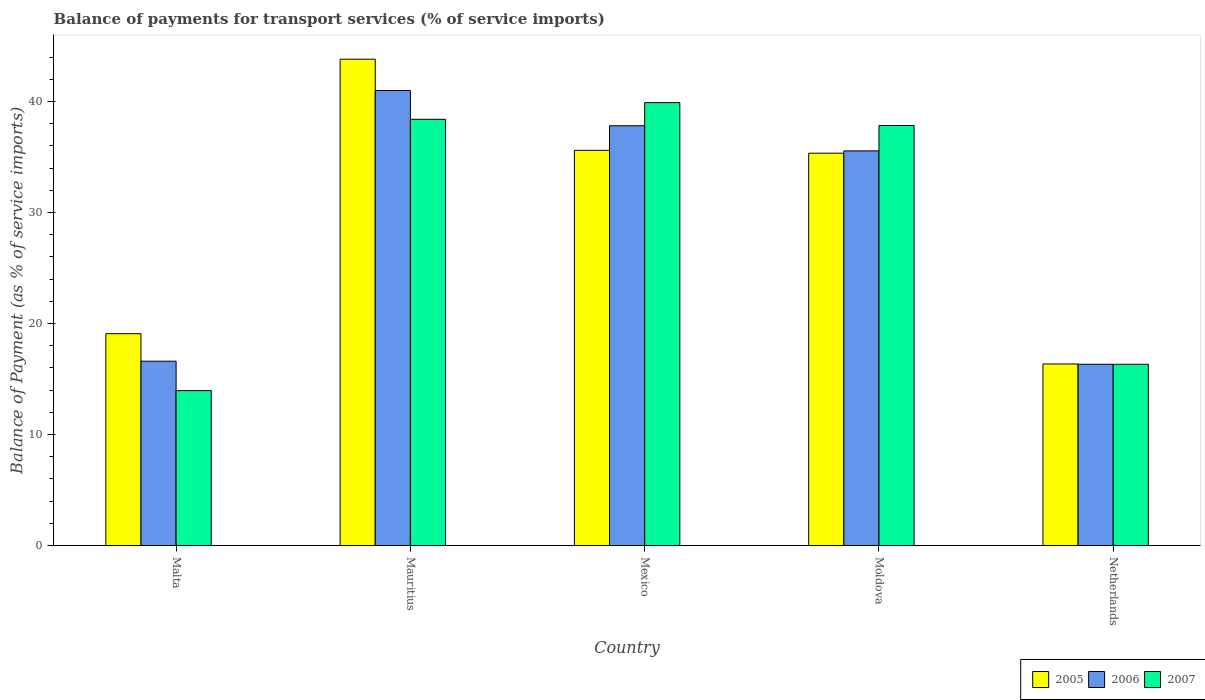How many different coloured bars are there?
Make the answer very short. 3. How many groups of bars are there?
Offer a terse response. 5. Are the number of bars per tick equal to the number of legend labels?
Ensure brevity in your answer.  Yes. What is the label of the 4th group of bars from the left?
Offer a terse response. Moldova. In how many cases, is the number of bars for a given country not equal to the number of legend labels?
Ensure brevity in your answer.  0. What is the balance of payments for transport services in 2007 in Moldova?
Offer a terse response. 37.83. Across all countries, what is the maximum balance of payments for transport services in 2007?
Give a very brief answer. 39.9. Across all countries, what is the minimum balance of payments for transport services in 2005?
Provide a succinct answer. 16.35. In which country was the balance of payments for transport services in 2007 maximum?
Your response must be concise. Mexico. In which country was the balance of payments for transport services in 2005 minimum?
Ensure brevity in your answer.  Netherlands. What is the total balance of payments for transport services in 2005 in the graph?
Offer a very short reply. 150.18. What is the difference between the balance of payments for transport services in 2005 in Malta and that in Mauritius?
Make the answer very short. -24.72. What is the difference between the balance of payments for transport services in 2007 in Moldova and the balance of payments for transport services in 2006 in Mauritius?
Offer a very short reply. -3.15. What is the average balance of payments for transport services in 2005 per country?
Your answer should be very brief. 30.04. What is the difference between the balance of payments for transport services of/in 2007 and balance of payments for transport services of/in 2005 in Mexico?
Your answer should be compact. 4.3. In how many countries, is the balance of payments for transport services in 2005 greater than 22 %?
Offer a very short reply. 3. What is the ratio of the balance of payments for transport services in 2005 in Mauritius to that in Mexico?
Your answer should be compact. 1.23. Is the difference between the balance of payments for transport services in 2007 in Malta and Mauritius greater than the difference between the balance of payments for transport services in 2005 in Malta and Mauritius?
Provide a succinct answer. Yes. What is the difference between the highest and the second highest balance of payments for transport services in 2007?
Give a very brief answer. -0.56. What is the difference between the highest and the lowest balance of payments for transport services in 2006?
Provide a succinct answer. 24.65. How many countries are there in the graph?
Offer a very short reply. 5. Are the values on the major ticks of Y-axis written in scientific E-notation?
Provide a short and direct response. No. Does the graph contain grids?
Provide a succinct answer. No. What is the title of the graph?
Ensure brevity in your answer.  Balance of payments for transport services (% of service imports). Does "2014" appear as one of the legend labels in the graph?
Offer a terse response. No. What is the label or title of the X-axis?
Provide a succinct answer. Country. What is the label or title of the Y-axis?
Your answer should be compact. Balance of Payment (as % of service imports). What is the Balance of Payment (as % of service imports) in 2005 in Malta?
Your answer should be compact. 19.08. What is the Balance of Payment (as % of service imports) of 2006 in Malta?
Keep it short and to the point. 16.61. What is the Balance of Payment (as % of service imports) in 2007 in Malta?
Ensure brevity in your answer.  13.96. What is the Balance of Payment (as % of service imports) in 2005 in Mauritius?
Your answer should be compact. 43.81. What is the Balance of Payment (as % of service imports) of 2006 in Mauritius?
Your answer should be very brief. 40.98. What is the Balance of Payment (as % of service imports) of 2007 in Mauritius?
Offer a terse response. 38.39. What is the Balance of Payment (as % of service imports) of 2005 in Mexico?
Offer a terse response. 35.6. What is the Balance of Payment (as % of service imports) of 2006 in Mexico?
Your answer should be compact. 37.81. What is the Balance of Payment (as % of service imports) of 2007 in Mexico?
Give a very brief answer. 39.9. What is the Balance of Payment (as % of service imports) of 2005 in Moldova?
Your answer should be compact. 35.34. What is the Balance of Payment (as % of service imports) of 2006 in Moldova?
Keep it short and to the point. 35.55. What is the Balance of Payment (as % of service imports) in 2007 in Moldova?
Ensure brevity in your answer.  37.83. What is the Balance of Payment (as % of service imports) of 2005 in Netherlands?
Keep it short and to the point. 16.35. What is the Balance of Payment (as % of service imports) in 2006 in Netherlands?
Give a very brief answer. 16.33. What is the Balance of Payment (as % of service imports) of 2007 in Netherlands?
Your response must be concise. 16.33. Across all countries, what is the maximum Balance of Payment (as % of service imports) of 2005?
Ensure brevity in your answer.  43.81. Across all countries, what is the maximum Balance of Payment (as % of service imports) of 2006?
Ensure brevity in your answer.  40.98. Across all countries, what is the maximum Balance of Payment (as % of service imports) in 2007?
Give a very brief answer. 39.9. Across all countries, what is the minimum Balance of Payment (as % of service imports) in 2005?
Give a very brief answer. 16.35. Across all countries, what is the minimum Balance of Payment (as % of service imports) in 2006?
Provide a succinct answer. 16.33. Across all countries, what is the minimum Balance of Payment (as % of service imports) in 2007?
Provide a succinct answer. 13.96. What is the total Balance of Payment (as % of service imports) of 2005 in the graph?
Keep it short and to the point. 150.18. What is the total Balance of Payment (as % of service imports) of 2006 in the graph?
Offer a terse response. 147.28. What is the total Balance of Payment (as % of service imports) of 2007 in the graph?
Offer a very short reply. 146.41. What is the difference between the Balance of Payment (as % of service imports) of 2005 in Malta and that in Mauritius?
Offer a terse response. -24.72. What is the difference between the Balance of Payment (as % of service imports) in 2006 in Malta and that in Mauritius?
Your response must be concise. -24.38. What is the difference between the Balance of Payment (as % of service imports) in 2007 in Malta and that in Mauritius?
Give a very brief answer. -24.44. What is the difference between the Balance of Payment (as % of service imports) of 2005 in Malta and that in Mexico?
Offer a very short reply. -16.51. What is the difference between the Balance of Payment (as % of service imports) of 2006 in Malta and that in Mexico?
Give a very brief answer. -21.21. What is the difference between the Balance of Payment (as % of service imports) in 2007 in Malta and that in Mexico?
Your answer should be compact. -25.94. What is the difference between the Balance of Payment (as % of service imports) of 2005 in Malta and that in Moldova?
Offer a terse response. -16.25. What is the difference between the Balance of Payment (as % of service imports) in 2006 in Malta and that in Moldova?
Keep it short and to the point. -18.94. What is the difference between the Balance of Payment (as % of service imports) in 2007 in Malta and that in Moldova?
Offer a very short reply. -23.88. What is the difference between the Balance of Payment (as % of service imports) in 2005 in Malta and that in Netherlands?
Your response must be concise. 2.73. What is the difference between the Balance of Payment (as % of service imports) in 2006 in Malta and that in Netherlands?
Offer a very short reply. 0.28. What is the difference between the Balance of Payment (as % of service imports) of 2007 in Malta and that in Netherlands?
Give a very brief answer. -2.37. What is the difference between the Balance of Payment (as % of service imports) in 2005 in Mauritius and that in Mexico?
Your response must be concise. 8.21. What is the difference between the Balance of Payment (as % of service imports) in 2006 in Mauritius and that in Mexico?
Your response must be concise. 3.17. What is the difference between the Balance of Payment (as % of service imports) in 2007 in Mauritius and that in Mexico?
Ensure brevity in your answer.  -1.5. What is the difference between the Balance of Payment (as % of service imports) in 2005 in Mauritius and that in Moldova?
Offer a very short reply. 8.47. What is the difference between the Balance of Payment (as % of service imports) in 2006 in Mauritius and that in Moldova?
Your answer should be very brief. 5.43. What is the difference between the Balance of Payment (as % of service imports) in 2007 in Mauritius and that in Moldova?
Ensure brevity in your answer.  0.56. What is the difference between the Balance of Payment (as % of service imports) in 2005 in Mauritius and that in Netherlands?
Offer a very short reply. 27.45. What is the difference between the Balance of Payment (as % of service imports) in 2006 in Mauritius and that in Netherlands?
Your answer should be compact. 24.65. What is the difference between the Balance of Payment (as % of service imports) in 2007 in Mauritius and that in Netherlands?
Make the answer very short. 22.07. What is the difference between the Balance of Payment (as % of service imports) in 2005 in Mexico and that in Moldova?
Offer a very short reply. 0.26. What is the difference between the Balance of Payment (as % of service imports) of 2006 in Mexico and that in Moldova?
Offer a very short reply. 2.27. What is the difference between the Balance of Payment (as % of service imports) in 2007 in Mexico and that in Moldova?
Your answer should be compact. 2.06. What is the difference between the Balance of Payment (as % of service imports) of 2005 in Mexico and that in Netherlands?
Make the answer very short. 19.24. What is the difference between the Balance of Payment (as % of service imports) in 2006 in Mexico and that in Netherlands?
Provide a succinct answer. 21.48. What is the difference between the Balance of Payment (as % of service imports) of 2007 in Mexico and that in Netherlands?
Your response must be concise. 23.57. What is the difference between the Balance of Payment (as % of service imports) in 2005 in Moldova and that in Netherlands?
Provide a succinct answer. 18.98. What is the difference between the Balance of Payment (as % of service imports) in 2006 in Moldova and that in Netherlands?
Give a very brief answer. 19.22. What is the difference between the Balance of Payment (as % of service imports) in 2007 in Moldova and that in Netherlands?
Provide a short and direct response. 21.51. What is the difference between the Balance of Payment (as % of service imports) of 2005 in Malta and the Balance of Payment (as % of service imports) of 2006 in Mauritius?
Offer a terse response. -21.9. What is the difference between the Balance of Payment (as % of service imports) of 2005 in Malta and the Balance of Payment (as % of service imports) of 2007 in Mauritius?
Ensure brevity in your answer.  -19.31. What is the difference between the Balance of Payment (as % of service imports) in 2006 in Malta and the Balance of Payment (as % of service imports) in 2007 in Mauritius?
Your response must be concise. -21.79. What is the difference between the Balance of Payment (as % of service imports) in 2005 in Malta and the Balance of Payment (as % of service imports) in 2006 in Mexico?
Your response must be concise. -18.73. What is the difference between the Balance of Payment (as % of service imports) of 2005 in Malta and the Balance of Payment (as % of service imports) of 2007 in Mexico?
Your response must be concise. -20.81. What is the difference between the Balance of Payment (as % of service imports) in 2006 in Malta and the Balance of Payment (as % of service imports) in 2007 in Mexico?
Make the answer very short. -23.29. What is the difference between the Balance of Payment (as % of service imports) of 2005 in Malta and the Balance of Payment (as % of service imports) of 2006 in Moldova?
Keep it short and to the point. -16.46. What is the difference between the Balance of Payment (as % of service imports) of 2005 in Malta and the Balance of Payment (as % of service imports) of 2007 in Moldova?
Your answer should be compact. -18.75. What is the difference between the Balance of Payment (as % of service imports) of 2006 in Malta and the Balance of Payment (as % of service imports) of 2007 in Moldova?
Offer a very short reply. -21.23. What is the difference between the Balance of Payment (as % of service imports) in 2005 in Malta and the Balance of Payment (as % of service imports) in 2006 in Netherlands?
Provide a succinct answer. 2.76. What is the difference between the Balance of Payment (as % of service imports) in 2005 in Malta and the Balance of Payment (as % of service imports) in 2007 in Netherlands?
Provide a short and direct response. 2.76. What is the difference between the Balance of Payment (as % of service imports) of 2006 in Malta and the Balance of Payment (as % of service imports) of 2007 in Netherlands?
Offer a very short reply. 0.28. What is the difference between the Balance of Payment (as % of service imports) of 2005 in Mauritius and the Balance of Payment (as % of service imports) of 2006 in Mexico?
Your answer should be very brief. 5.99. What is the difference between the Balance of Payment (as % of service imports) of 2005 in Mauritius and the Balance of Payment (as % of service imports) of 2007 in Mexico?
Your answer should be compact. 3.91. What is the difference between the Balance of Payment (as % of service imports) of 2006 in Mauritius and the Balance of Payment (as % of service imports) of 2007 in Mexico?
Offer a terse response. 1.09. What is the difference between the Balance of Payment (as % of service imports) of 2005 in Mauritius and the Balance of Payment (as % of service imports) of 2006 in Moldova?
Give a very brief answer. 8.26. What is the difference between the Balance of Payment (as % of service imports) in 2005 in Mauritius and the Balance of Payment (as % of service imports) in 2007 in Moldova?
Offer a terse response. 5.97. What is the difference between the Balance of Payment (as % of service imports) in 2006 in Mauritius and the Balance of Payment (as % of service imports) in 2007 in Moldova?
Your response must be concise. 3.15. What is the difference between the Balance of Payment (as % of service imports) in 2005 in Mauritius and the Balance of Payment (as % of service imports) in 2006 in Netherlands?
Provide a short and direct response. 27.48. What is the difference between the Balance of Payment (as % of service imports) in 2005 in Mauritius and the Balance of Payment (as % of service imports) in 2007 in Netherlands?
Your response must be concise. 27.48. What is the difference between the Balance of Payment (as % of service imports) in 2006 in Mauritius and the Balance of Payment (as % of service imports) in 2007 in Netherlands?
Keep it short and to the point. 24.65. What is the difference between the Balance of Payment (as % of service imports) of 2005 in Mexico and the Balance of Payment (as % of service imports) of 2006 in Moldova?
Offer a terse response. 0.05. What is the difference between the Balance of Payment (as % of service imports) in 2005 in Mexico and the Balance of Payment (as % of service imports) in 2007 in Moldova?
Provide a short and direct response. -2.24. What is the difference between the Balance of Payment (as % of service imports) of 2006 in Mexico and the Balance of Payment (as % of service imports) of 2007 in Moldova?
Make the answer very short. -0.02. What is the difference between the Balance of Payment (as % of service imports) in 2005 in Mexico and the Balance of Payment (as % of service imports) in 2006 in Netherlands?
Provide a succinct answer. 19.27. What is the difference between the Balance of Payment (as % of service imports) of 2005 in Mexico and the Balance of Payment (as % of service imports) of 2007 in Netherlands?
Ensure brevity in your answer.  19.27. What is the difference between the Balance of Payment (as % of service imports) in 2006 in Mexico and the Balance of Payment (as % of service imports) in 2007 in Netherlands?
Ensure brevity in your answer.  21.49. What is the difference between the Balance of Payment (as % of service imports) in 2005 in Moldova and the Balance of Payment (as % of service imports) in 2006 in Netherlands?
Give a very brief answer. 19.01. What is the difference between the Balance of Payment (as % of service imports) of 2005 in Moldova and the Balance of Payment (as % of service imports) of 2007 in Netherlands?
Your answer should be compact. 19.01. What is the difference between the Balance of Payment (as % of service imports) in 2006 in Moldova and the Balance of Payment (as % of service imports) in 2007 in Netherlands?
Keep it short and to the point. 19.22. What is the average Balance of Payment (as % of service imports) of 2005 per country?
Provide a succinct answer. 30.04. What is the average Balance of Payment (as % of service imports) of 2006 per country?
Offer a very short reply. 29.46. What is the average Balance of Payment (as % of service imports) in 2007 per country?
Provide a short and direct response. 29.28. What is the difference between the Balance of Payment (as % of service imports) in 2005 and Balance of Payment (as % of service imports) in 2006 in Malta?
Make the answer very short. 2.48. What is the difference between the Balance of Payment (as % of service imports) in 2005 and Balance of Payment (as % of service imports) in 2007 in Malta?
Give a very brief answer. 5.13. What is the difference between the Balance of Payment (as % of service imports) in 2006 and Balance of Payment (as % of service imports) in 2007 in Malta?
Offer a very short reply. 2.65. What is the difference between the Balance of Payment (as % of service imports) of 2005 and Balance of Payment (as % of service imports) of 2006 in Mauritius?
Provide a succinct answer. 2.82. What is the difference between the Balance of Payment (as % of service imports) of 2005 and Balance of Payment (as % of service imports) of 2007 in Mauritius?
Your answer should be compact. 5.41. What is the difference between the Balance of Payment (as % of service imports) in 2006 and Balance of Payment (as % of service imports) in 2007 in Mauritius?
Your answer should be compact. 2.59. What is the difference between the Balance of Payment (as % of service imports) of 2005 and Balance of Payment (as % of service imports) of 2006 in Mexico?
Keep it short and to the point. -2.22. What is the difference between the Balance of Payment (as % of service imports) of 2005 and Balance of Payment (as % of service imports) of 2007 in Mexico?
Make the answer very short. -4.3. What is the difference between the Balance of Payment (as % of service imports) of 2006 and Balance of Payment (as % of service imports) of 2007 in Mexico?
Make the answer very short. -2.08. What is the difference between the Balance of Payment (as % of service imports) of 2005 and Balance of Payment (as % of service imports) of 2006 in Moldova?
Keep it short and to the point. -0.21. What is the difference between the Balance of Payment (as % of service imports) in 2005 and Balance of Payment (as % of service imports) in 2007 in Moldova?
Your answer should be very brief. -2.49. What is the difference between the Balance of Payment (as % of service imports) of 2006 and Balance of Payment (as % of service imports) of 2007 in Moldova?
Keep it short and to the point. -2.29. What is the difference between the Balance of Payment (as % of service imports) of 2005 and Balance of Payment (as % of service imports) of 2006 in Netherlands?
Your answer should be compact. 0.03. What is the difference between the Balance of Payment (as % of service imports) in 2005 and Balance of Payment (as % of service imports) in 2007 in Netherlands?
Provide a succinct answer. 0.03. What is the difference between the Balance of Payment (as % of service imports) in 2006 and Balance of Payment (as % of service imports) in 2007 in Netherlands?
Offer a very short reply. 0. What is the ratio of the Balance of Payment (as % of service imports) in 2005 in Malta to that in Mauritius?
Offer a very short reply. 0.44. What is the ratio of the Balance of Payment (as % of service imports) of 2006 in Malta to that in Mauritius?
Provide a short and direct response. 0.41. What is the ratio of the Balance of Payment (as % of service imports) in 2007 in Malta to that in Mauritius?
Provide a short and direct response. 0.36. What is the ratio of the Balance of Payment (as % of service imports) of 2005 in Malta to that in Mexico?
Provide a short and direct response. 0.54. What is the ratio of the Balance of Payment (as % of service imports) of 2006 in Malta to that in Mexico?
Offer a very short reply. 0.44. What is the ratio of the Balance of Payment (as % of service imports) of 2007 in Malta to that in Mexico?
Your answer should be compact. 0.35. What is the ratio of the Balance of Payment (as % of service imports) in 2005 in Malta to that in Moldova?
Provide a short and direct response. 0.54. What is the ratio of the Balance of Payment (as % of service imports) of 2006 in Malta to that in Moldova?
Ensure brevity in your answer.  0.47. What is the ratio of the Balance of Payment (as % of service imports) in 2007 in Malta to that in Moldova?
Offer a very short reply. 0.37. What is the ratio of the Balance of Payment (as % of service imports) in 2005 in Malta to that in Netherlands?
Offer a terse response. 1.17. What is the ratio of the Balance of Payment (as % of service imports) of 2006 in Malta to that in Netherlands?
Make the answer very short. 1.02. What is the ratio of the Balance of Payment (as % of service imports) of 2007 in Malta to that in Netherlands?
Keep it short and to the point. 0.85. What is the ratio of the Balance of Payment (as % of service imports) in 2005 in Mauritius to that in Mexico?
Ensure brevity in your answer.  1.23. What is the ratio of the Balance of Payment (as % of service imports) of 2006 in Mauritius to that in Mexico?
Your answer should be very brief. 1.08. What is the ratio of the Balance of Payment (as % of service imports) in 2007 in Mauritius to that in Mexico?
Make the answer very short. 0.96. What is the ratio of the Balance of Payment (as % of service imports) in 2005 in Mauritius to that in Moldova?
Make the answer very short. 1.24. What is the ratio of the Balance of Payment (as % of service imports) of 2006 in Mauritius to that in Moldova?
Provide a succinct answer. 1.15. What is the ratio of the Balance of Payment (as % of service imports) in 2007 in Mauritius to that in Moldova?
Make the answer very short. 1.01. What is the ratio of the Balance of Payment (as % of service imports) of 2005 in Mauritius to that in Netherlands?
Ensure brevity in your answer.  2.68. What is the ratio of the Balance of Payment (as % of service imports) of 2006 in Mauritius to that in Netherlands?
Ensure brevity in your answer.  2.51. What is the ratio of the Balance of Payment (as % of service imports) of 2007 in Mauritius to that in Netherlands?
Your response must be concise. 2.35. What is the ratio of the Balance of Payment (as % of service imports) of 2005 in Mexico to that in Moldova?
Make the answer very short. 1.01. What is the ratio of the Balance of Payment (as % of service imports) in 2006 in Mexico to that in Moldova?
Your answer should be compact. 1.06. What is the ratio of the Balance of Payment (as % of service imports) of 2007 in Mexico to that in Moldova?
Your answer should be very brief. 1.05. What is the ratio of the Balance of Payment (as % of service imports) in 2005 in Mexico to that in Netherlands?
Provide a short and direct response. 2.18. What is the ratio of the Balance of Payment (as % of service imports) in 2006 in Mexico to that in Netherlands?
Ensure brevity in your answer.  2.32. What is the ratio of the Balance of Payment (as % of service imports) of 2007 in Mexico to that in Netherlands?
Ensure brevity in your answer.  2.44. What is the ratio of the Balance of Payment (as % of service imports) of 2005 in Moldova to that in Netherlands?
Offer a very short reply. 2.16. What is the ratio of the Balance of Payment (as % of service imports) in 2006 in Moldova to that in Netherlands?
Your answer should be compact. 2.18. What is the ratio of the Balance of Payment (as % of service imports) in 2007 in Moldova to that in Netherlands?
Ensure brevity in your answer.  2.32. What is the difference between the highest and the second highest Balance of Payment (as % of service imports) of 2005?
Give a very brief answer. 8.21. What is the difference between the highest and the second highest Balance of Payment (as % of service imports) in 2006?
Give a very brief answer. 3.17. What is the difference between the highest and the second highest Balance of Payment (as % of service imports) of 2007?
Your response must be concise. 1.5. What is the difference between the highest and the lowest Balance of Payment (as % of service imports) in 2005?
Make the answer very short. 27.45. What is the difference between the highest and the lowest Balance of Payment (as % of service imports) of 2006?
Your answer should be very brief. 24.65. What is the difference between the highest and the lowest Balance of Payment (as % of service imports) of 2007?
Provide a succinct answer. 25.94. 